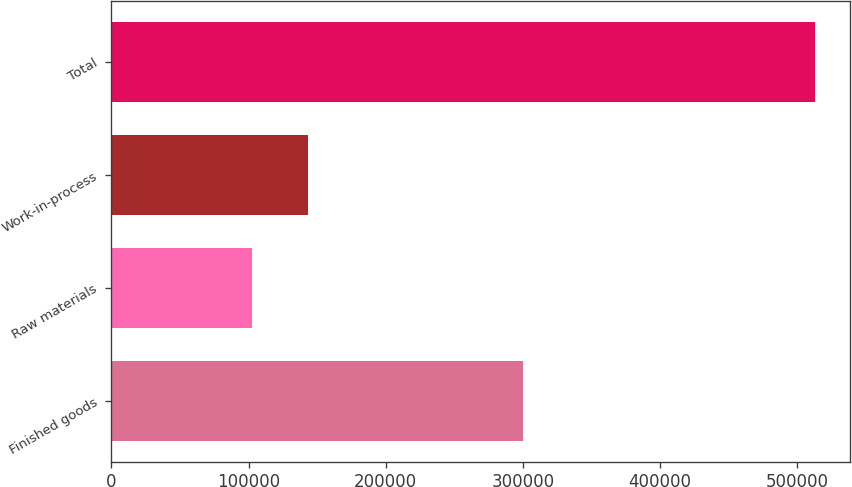Convert chart. <chart><loc_0><loc_0><loc_500><loc_500><bar_chart><fcel>Finished goods<fcel>Raw materials<fcel>Work-in-process<fcel>Total<nl><fcel>299975<fcel>102563<fcel>143577<fcel>512707<nl></chart> 